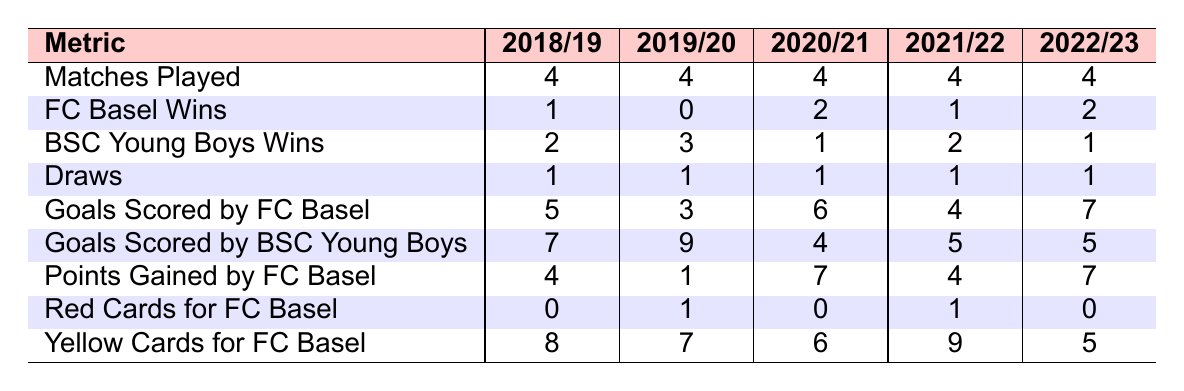What was FC Basel's total number of wins against BSC Young Boys in the past 5 seasons? By counting the wins from each season for FC Basel: 1 (2018/19) + 0 (2019/20) + 2 (2020/21) + 1 (2021/22) + 2 (2022/23) = 6 total wins.
Answer: 6 In which season did FC Basel score the most goals against BSC Young Boys? The goals scored by FC Basel are as follows: 5 (2018/19), 3 (2019/20), 6 (2020/21), 4 (2021/22), and 7 (2022/23). The highest value is 7 in the 2022/23 season.
Answer: 2022/23 How many total matches were played between FC Basel and BSC Young Boys in the past 5 seasons? Each season had 4 matches played, so the total is calculated as 4 (matches per season) * 5 (seasons) = 20 matches.
Answer: 20 What was the average number of goals scored by BSC Young Boys across the 5 seasons? The goals scored by BSC Young Boys are: 7, 9, 4, 5, 5. Adding them gives 30, and dividing by 5 seasons results in an average of 30 / 5 = 6.
Answer: 6 Did FC Basel ever win more matches than BSC Young Boys in any season? Reviewing the win counts per season: FC Basel wins are 1, 0, 2, 1, 2 while BSC Young Boys wins are 2, 3, 1, 2, 1. In all seasons, FC Basel lost more or the same matches to BSC Young Boys.
Answer: No What was the total number of yellow cards received by FC Basel across all the seasons? The yellow cards for FC Basel are: 8, 7, 6, 9, 5. Summing these gives 8 + 7 + 6 + 9 + 5 = 35 yellow cards in total.
Answer: 35 Was there a season where FC Basel received no red cards? Evaluating red cards, we see they received 0 (2018/19), 1 (2019/20), 0 (2020/21), 1 (2021/22), and 0 (2022/23). There are seasons (2018/19, 2020/21, 2022/23) where no red cards were issued.
Answer: Yes In how many seasons did both teams draw the matches against each other? The draws recorded were 1 for each season: 2018/19, 2019/20, 2020/21, 2021/22, 2022/23. All seasons had 1 draw. Therefore, the answer is 5 seasons.
Answer: 5 